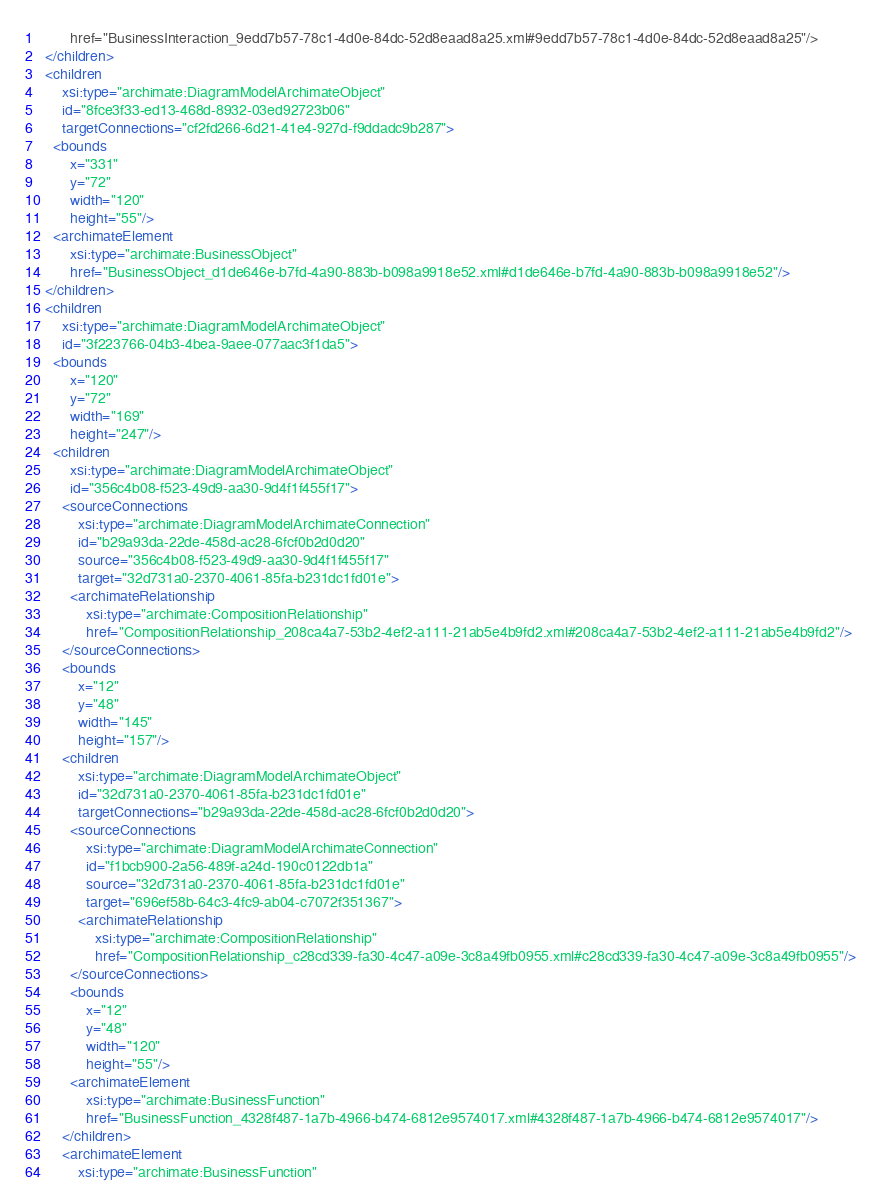<code> <loc_0><loc_0><loc_500><loc_500><_XML_>        href="BusinessInteraction_9edd7b57-78c1-4d0e-84dc-52d8eaad8a25.xml#9edd7b57-78c1-4d0e-84dc-52d8eaad8a25"/>
  </children>
  <children
      xsi:type="archimate:DiagramModelArchimateObject"
      id="8fce3f33-ed13-468d-8932-03ed92723b06"
      targetConnections="cf2fd266-6d21-41e4-927d-f9ddadc9b287">
    <bounds
        x="331"
        y="72"
        width="120"
        height="55"/>
    <archimateElement
        xsi:type="archimate:BusinessObject"
        href="BusinessObject_d1de646e-b7fd-4a90-883b-b098a9918e52.xml#d1de646e-b7fd-4a90-883b-b098a9918e52"/>
  </children>
  <children
      xsi:type="archimate:DiagramModelArchimateObject"
      id="3f223766-04b3-4bea-9aee-077aac3f1da5">
    <bounds
        x="120"
        y="72"
        width="169"
        height="247"/>
    <children
        xsi:type="archimate:DiagramModelArchimateObject"
        id="356c4b08-f523-49d9-aa30-9d4f1f455f17">
      <sourceConnections
          xsi:type="archimate:DiagramModelArchimateConnection"
          id="b29a93da-22de-458d-ac28-6fcf0b2d0d20"
          source="356c4b08-f523-49d9-aa30-9d4f1f455f17"
          target="32d731a0-2370-4061-85fa-b231dc1fd01e">
        <archimateRelationship
            xsi:type="archimate:CompositionRelationship"
            href="CompositionRelationship_208ca4a7-53b2-4ef2-a111-21ab5e4b9fd2.xml#208ca4a7-53b2-4ef2-a111-21ab5e4b9fd2"/>
      </sourceConnections>
      <bounds
          x="12"
          y="48"
          width="145"
          height="157"/>
      <children
          xsi:type="archimate:DiagramModelArchimateObject"
          id="32d731a0-2370-4061-85fa-b231dc1fd01e"
          targetConnections="b29a93da-22de-458d-ac28-6fcf0b2d0d20">
        <sourceConnections
            xsi:type="archimate:DiagramModelArchimateConnection"
            id="f1bcb900-2a56-489f-a24d-190c0122db1a"
            source="32d731a0-2370-4061-85fa-b231dc1fd01e"
            target="696ef58b-64c3-4fc9-ab04-c7072f351367">
          <archimateRelationship
              xsi:type="archimate:CompositionRelationship"
              href="CompositionRelationship_c28cd339-fa30-4c47-a09e-3c8a49fb0955.xml#c28cd339-fa30-4c47-a09e-3c8a49fb0955"/>
        </sourceConnections>
        <bounds
            x="12"
            y="48"
            width="120"
            height="55"/>
        <archimateElement
            xsi:type="archimate:BusinessFunction"
            href="BusinessFunction_4328f487-1a7b-4966-b474-6812e9574017.xml#4328f487-1a7b-4966-b474-6812e9574017"/>
      </children>
      <archimateElement
          xsi:type="archimate:BusinessFunction"</code> 